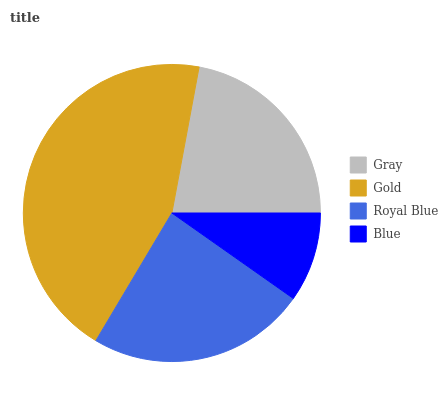Is Blue the minimum?
Answer yes or no. Yes. Is Gold the maximum?
Answer yes or no. Yes. Is Royal Blue the minimum?
Answer yes or no. No. Is Royal Blue the maximum?
Answer yes or no. No. Is Gold greater than Royal Blue?
Answer yes or no. Yes. Is Royal Blue less than Gold?
Answer yes or no. Yes. Is Royal Blue greater than Gold?
Answer yes or no. No. Is Gold less than Royal Blue?
Answer yes or no. No. Is Royal Blue the high median?
Answer yes or no. Yes. Is Gray the low median?
Answer yes or no. Yes. Is Blue the high median?
Answer yes or no. No. Is Blue the low median?
Answer yes or no. No. 